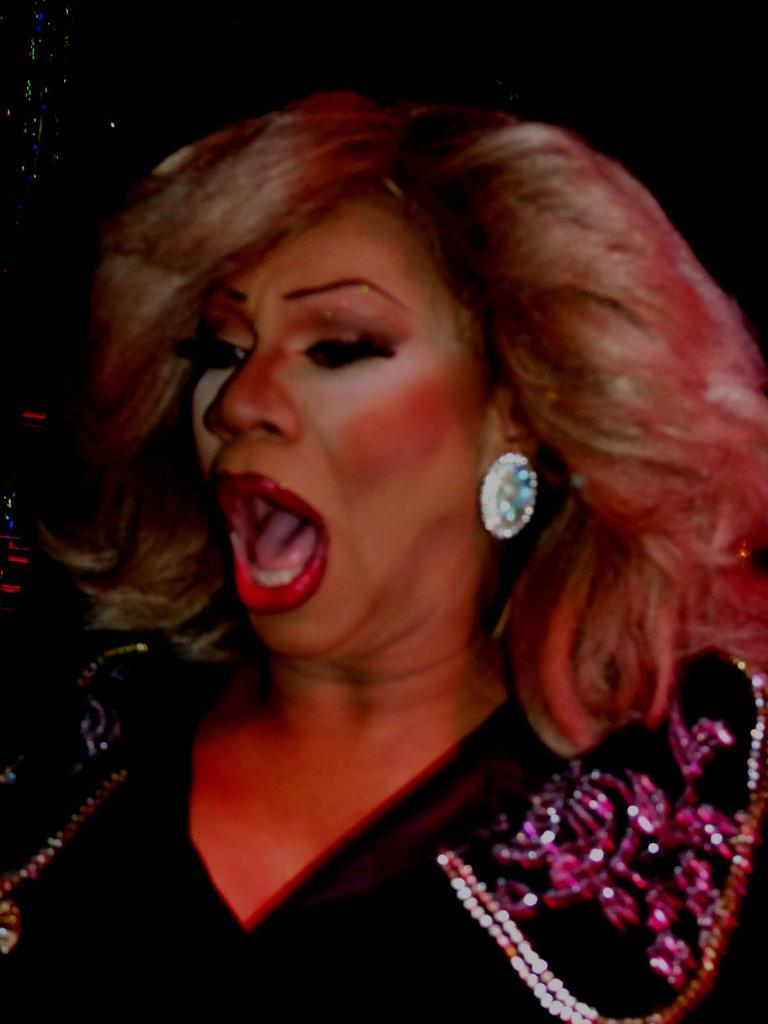Who is present in the image? There is a woman in the image. What month is depicted in the image? There is no month depicted in the image, as it features a woman and does not include any reference to a specific time or date. 